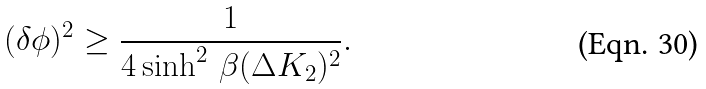Convert formula to latex. <formula><loc_0><loc_0><loc_500><loc_500>( \delta \phi ) ^ { 2 } \geq \frac { 1 } { 4 \sinh ^ { 2 } \, \beta ( \Delta K _ { 2 } ) ^ { 2 } } .</formula> 